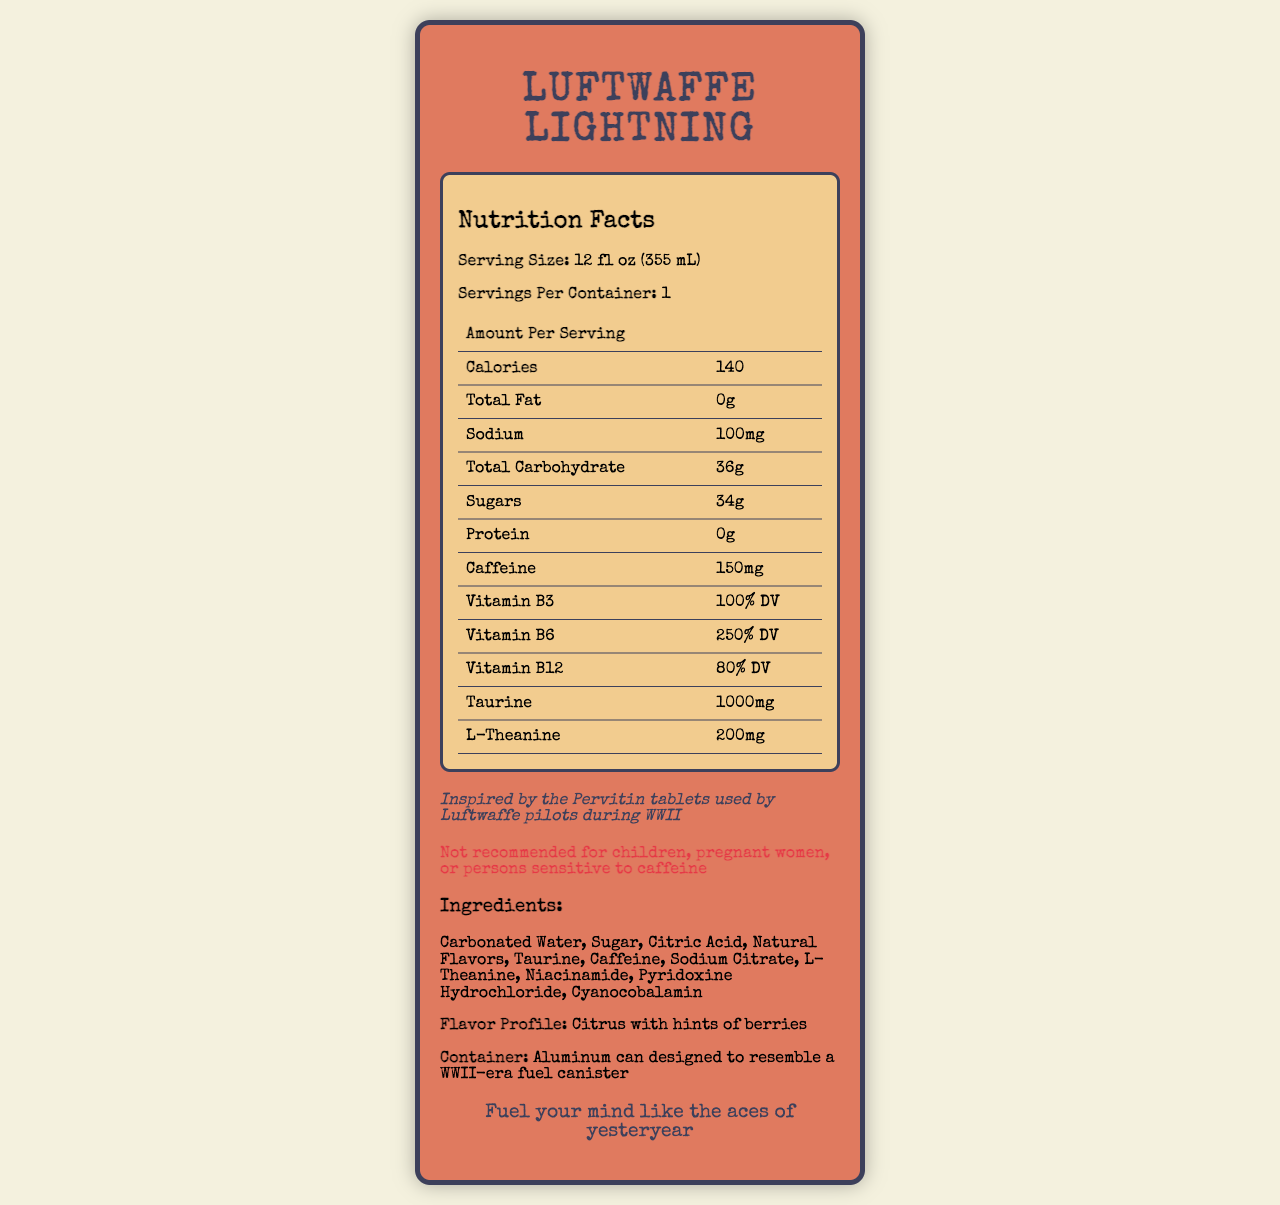what is the serving size? The serving size is listed under the Nutrition Facts section directly.
Answer: 12 fl oz (355 mL) how many calories are there per serving? The calories per serving are listed in the Nutrition Facts section as "Amount Per Serving Calories 140".
Answer: 140 how much caffeine is in one serving? The caffeine content is listed in the Nutrition Facts table as "Caffeine 150mg".
Answer: 150mg what is the percentage of Vitamin B6 provided per serving? The Nutrition Facts section lists "Vitamin B6 250% DV".
Answer: 250% DV what is the primary flavor profile of the energy drink? The flavor profile is mentioned towards the end of the document as "Flavor Profile: Citrus with hints of berries".
Answer: Citrus with hints of berries which ingredient is mentioned first? A. Taurine B. Caffeine C. Carbonated Water The first ingredient listed is "Carbonated Water".
Answer: C. Carbonated Water how much sodium is in one serving? The sodium content is listed in the Nutrition Facts table as "Sodium 100mg".
Answer: 100mg Who inspired the product? A. British RAF B. American Air Force C. Luftwaffe pilots The historical blurb states "Inspired by the Pervitin tablets used by Luftwaffe pilots during WWII".
Answer: C. Luftwaffe pilots is this product recommended for children? The warning section clearly states "Not recommended for children".
Answer: No summarize the key features of the energy drink. The document provides details on serving size, calories, caffeine content, vitamins and other ingredients, flavor profile, design inspiration, and a warning for certain groups of people.
Answer: The "Luftwaffe Lightning" energy drink is inspired by stimulants used by WWII Luftwaffe pilots. It comes as a 12 fl oz serving per container, with 140 calories, 150mg caffeine, and no fat or protein. The drink provides significant daily values of vitamins B3, B6, B12, and contains taurine and L-theanine. It has a citrus and berry flavor, and warnings against use by children, pregnant women, and those sensitive to caffeine. The can design resembles a WWII-era fuel canister with a marketing tagline "Fuel your mind like the aces of yesteryear". can we determine the effects of Pervitin tablets on pilots from this document? The document mentions Pervitin tablets in the historical blurb but does not provide details on their effects on pilots.
Answer: Not enough information 